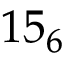<formula> <loc_0><loc_0><loc_500><loc_500>1 5 _ { 6 }</formula> 